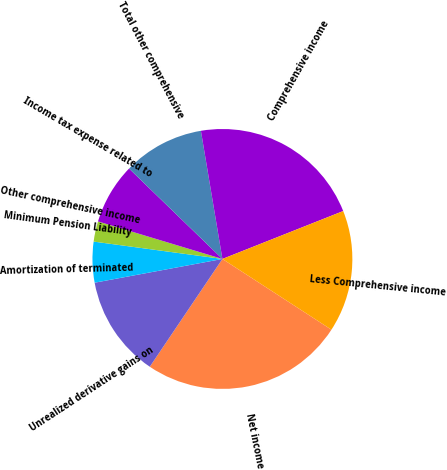<chart> <loc_0><loc_0><loc_500><loc_500><pie_chart><fcel>Net income<fcel>Unrealized derivative gains on<fcel>Amortization of terminated<fcel>Minimum Pension Liability<fcel>Other comprehensive income<fcel>Income tax expense related to<fcel>Total other comprehensive<fcel>Comprehensive income<fcel>Less Comprehensive income<nl><fcel>25.28%<fcel>12.64%<fcel>5.06%<fcel>0.0%<fcel>2.53%<fcel>7.58%<fcel>10.11%<fcel>21.64%<fcel>15.17%<nl></chart> 